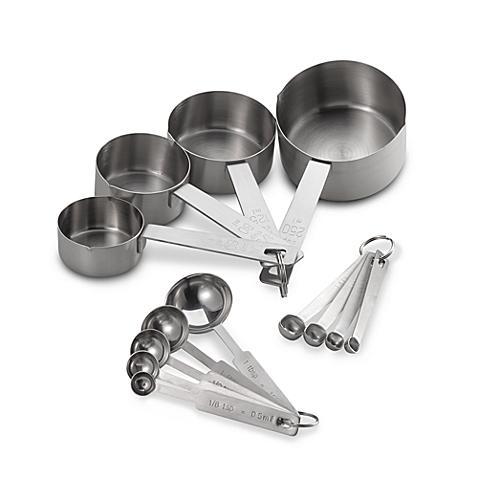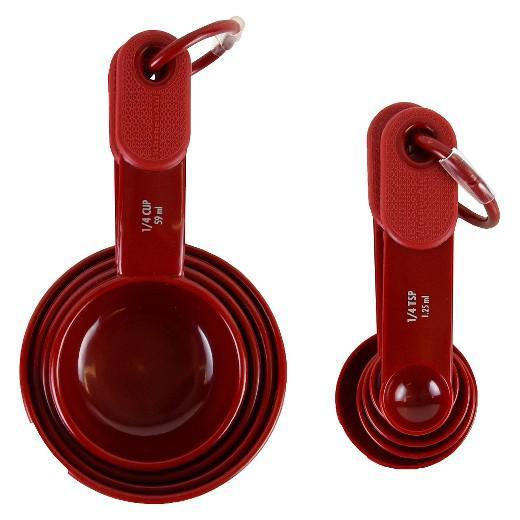The first image is the image on the left, the second image is the image on the right. For the images displayed, is the sentence "An image features measuring utensils with blue coloring." factually correct? Answer yes or no. No. 